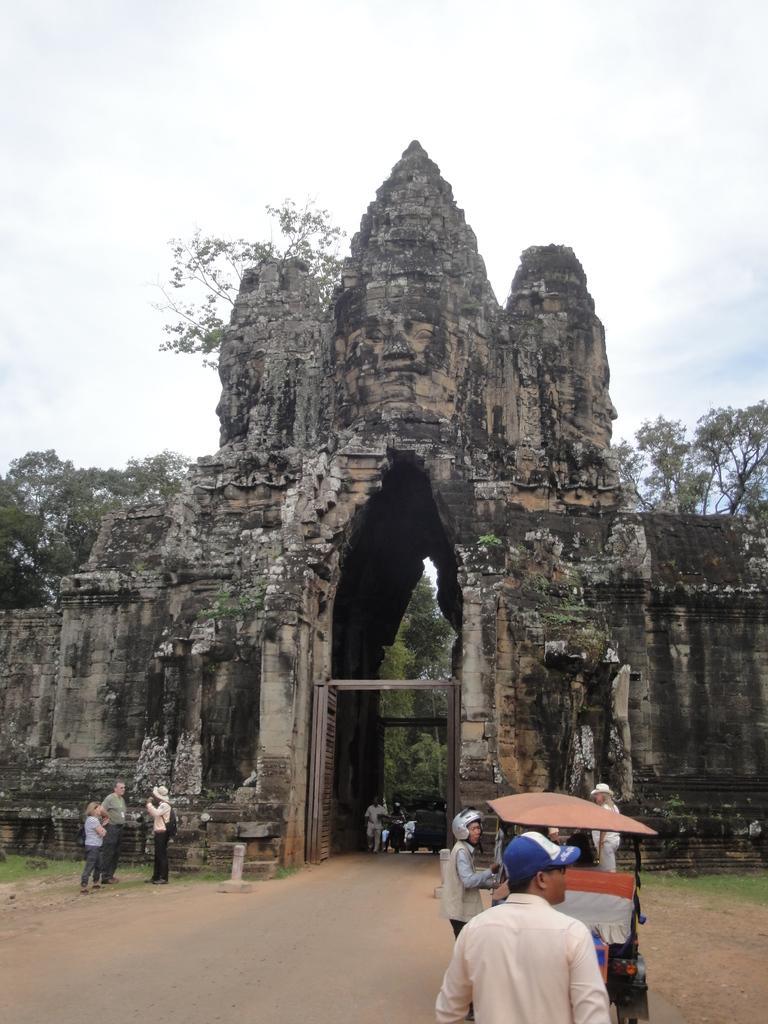How would you summarize this image in a sentence or two? In this image we can see an ancient architecture. There are many people. Also there is a cart. In the background there are trees and sky with clouds. 